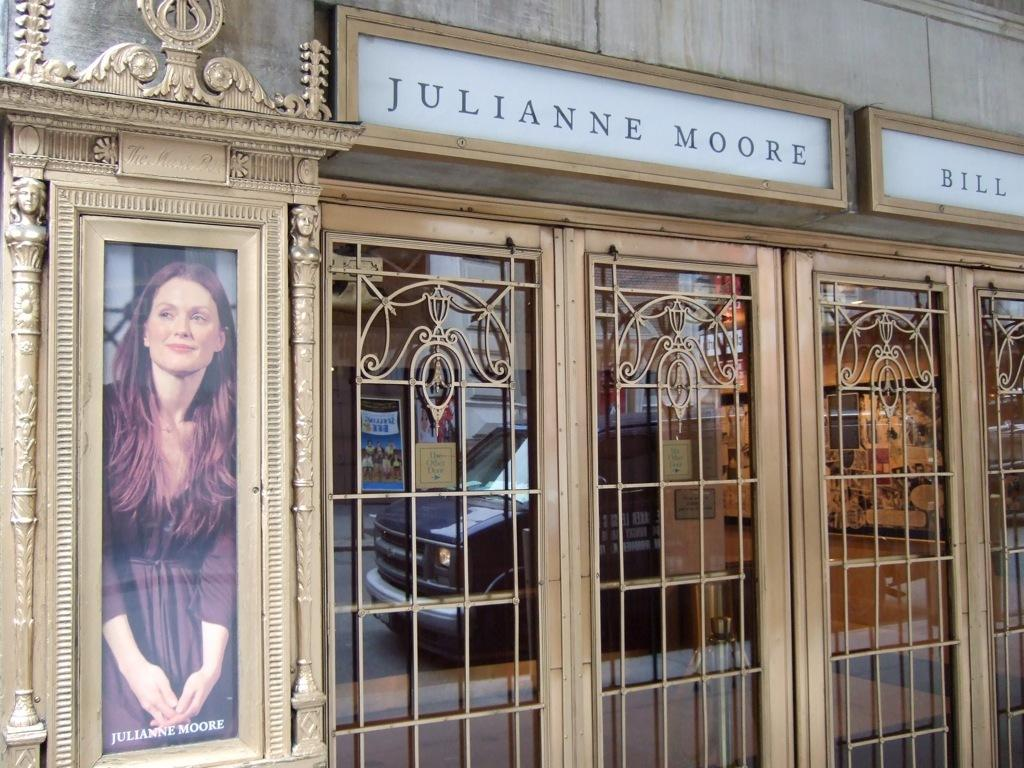<image>
Relay a brief, clear account of the picture shown. the outside of a building with a sign above the windows that says 'julianne moore' 